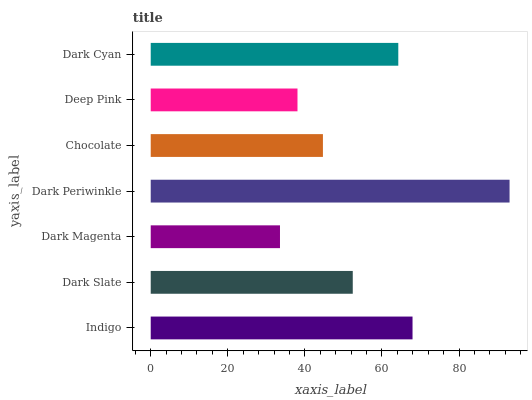Is Dark Magenta the minimum?
Answer yes or no. Yes. Is Dark Periwinkle the maximum?
Answer yes or no. Yes. Is Dark Slate the minimum?
Answer yes or no. No. Is Dark Slate the maximum?
Answer yes or no. No. Is Indigo greater than Dark Slate?
Answer yes or no. Yes. Is Dark Slate less than Indigo?
Answer yes or no. Yes. Is Dark Slate greater than Indigo?
Answer yes or no. No. Is Indigo less than Dark Slate?
Answer yes or no. No. Is Dark Slate the high median?
Answer yes or no. Yes. Is Dark Slate the low median?
Answer yes or no. Yes. Is Dark Cyan the high median?
Answer yes or no. No. Is Dark Cyan the low median?
Answer yes or no. No. 